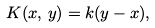<formula> <loc_0><loc_0><loc_500><loc_500>K ( x , \, y ) = k ( y - x ) ,</formula> 